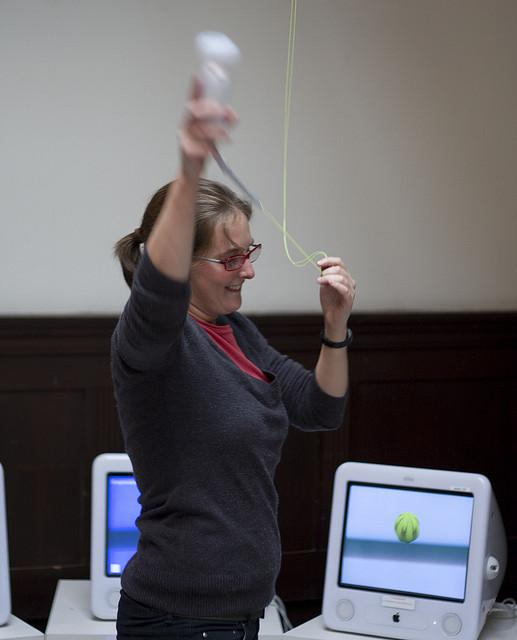What kind of computer is near the woman in blue? Please explain your reasoning. macintosh. The computer is a mac. 